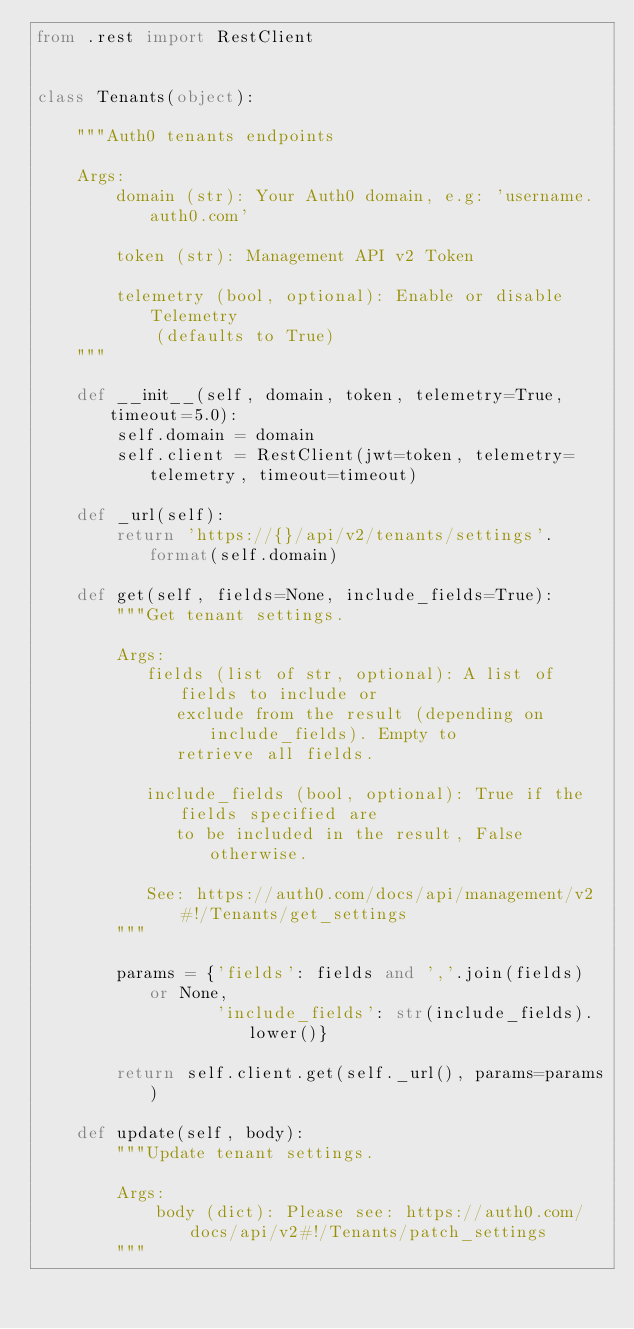Convert code to text. <code><loc_0><loc_0><loc_500><loc_500><_Python_>from .rest import RestClient


class Tenants(object):

    """Auth0 tenants endpoints

    Args:
        domain (str): Your Auth0 domain, e.g: 'username.auth0.com'

        token (str): Management API v2 Token

        telemetry (bool, optional): Enable or disable Telemetry
            (defaults to True)
    """

    def __init__(self, domain, token, telemetry=True, timeout=5.0):
        self.domain = domain
        self.client = RestClient(jwt=token, telemetry=telemetry, timeout=timeout)

    def _url(self):
        return 'https://{}/api/v2/tenants/settings'.format(self.domain)

    def get(self, fields=None, include_fields=True):
        """Get tenant settings.

        Args:
           fields (list of str, optional): A list of fields to include or
              exclude from the result (depending on include_fields). Empty to
              retrieve all fields.

           include_fields (bool, optional): True if the fields specified are
              to be included in the result, False otherwise.
              
           See: https://auth0.com/docs/api/management/v2#!/Tenants/get_settings
        """

        params = {'fields': fields and ','.join(fields) or None,
                  'include_fields': str(include_fields).lower()}

        return self.client.get(self._url(), params=params)

    def update(self, body):
        """Update tenant settings.

        Args:
            body (dict): Please see: https://auth0.com/docs/api/v2#!/Tenants/patch_settings
        """</code> 